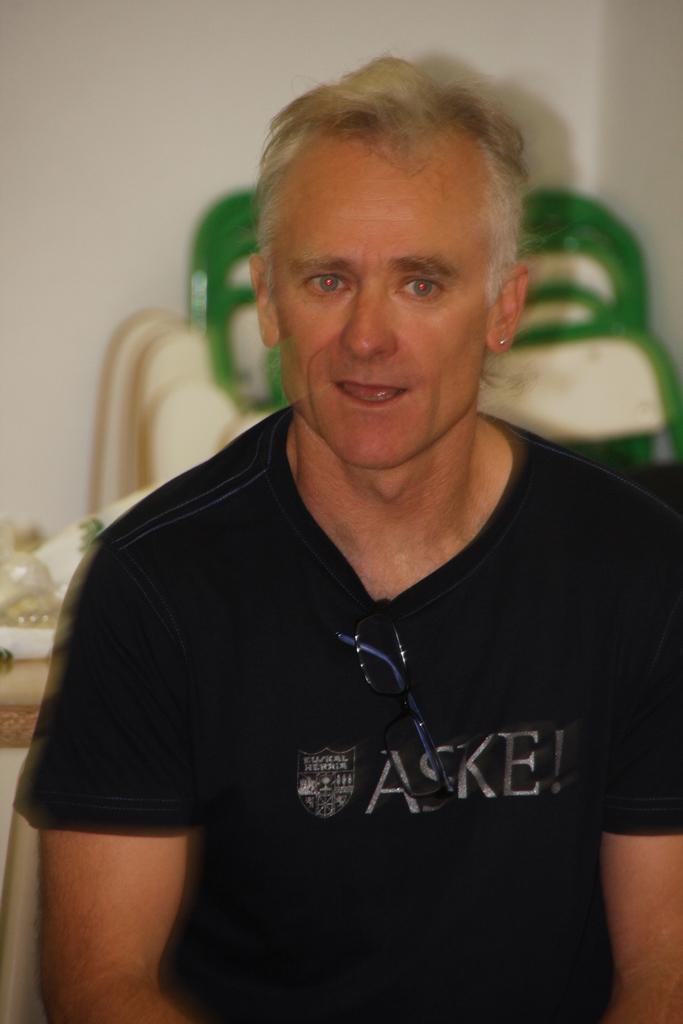Could you give a brief overview of what you see in this image? In this picture there is a person with black t-shirt. At the back there are chairs and there are objects on the table and there is a wall. 